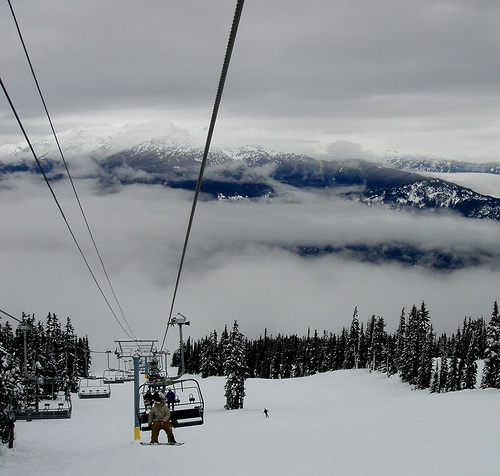Describe the objects in this image and their specific colors. I can see people in darkgray, black, and gray tones, people in darkgray, black, gray, and lightgray tones, snowboard in darkgray, gray, and black tones, people in darkgray, black, gray, and maroon tones, and people in darkgray, black, maroon, and gray tones in this image. 